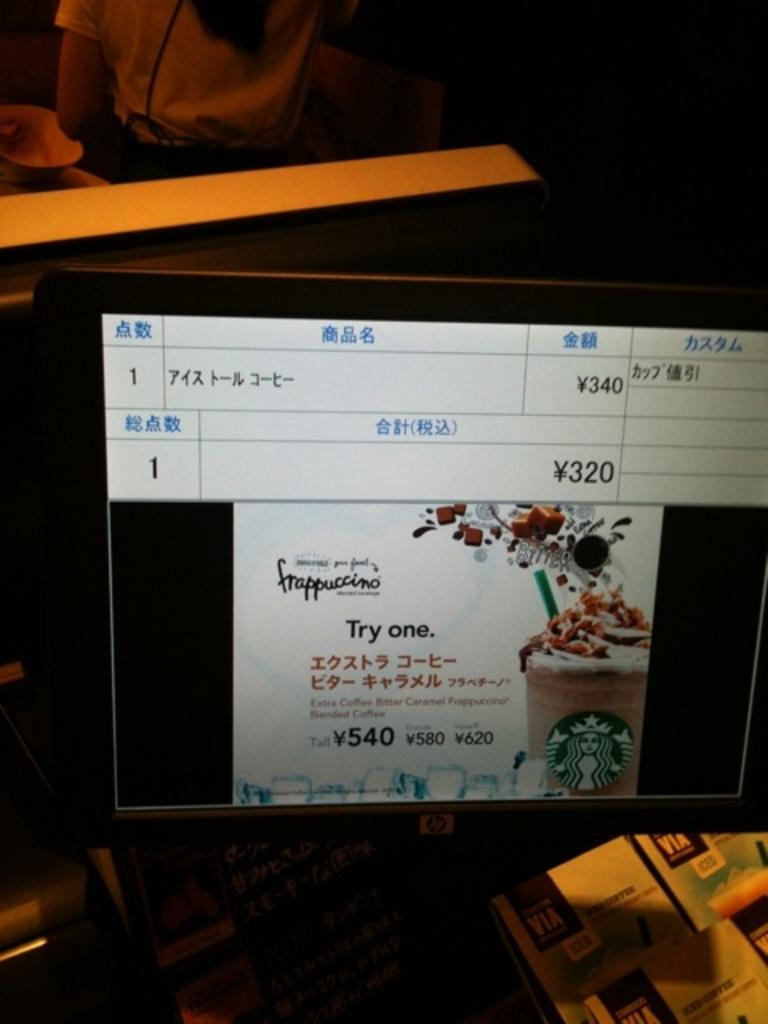<image>
Give a short and clear explanation of the subsequent image. An hp screen at Starbucks says to try a frappuccino. 